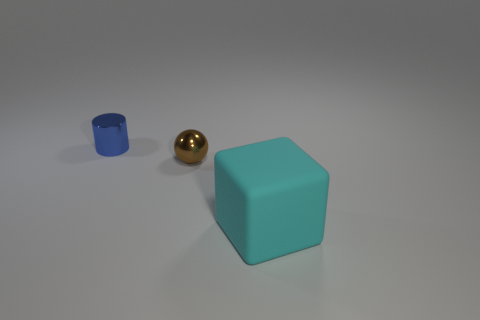There is a cylinder that is made of the same material as the tiny sphere; what color is it? blue 